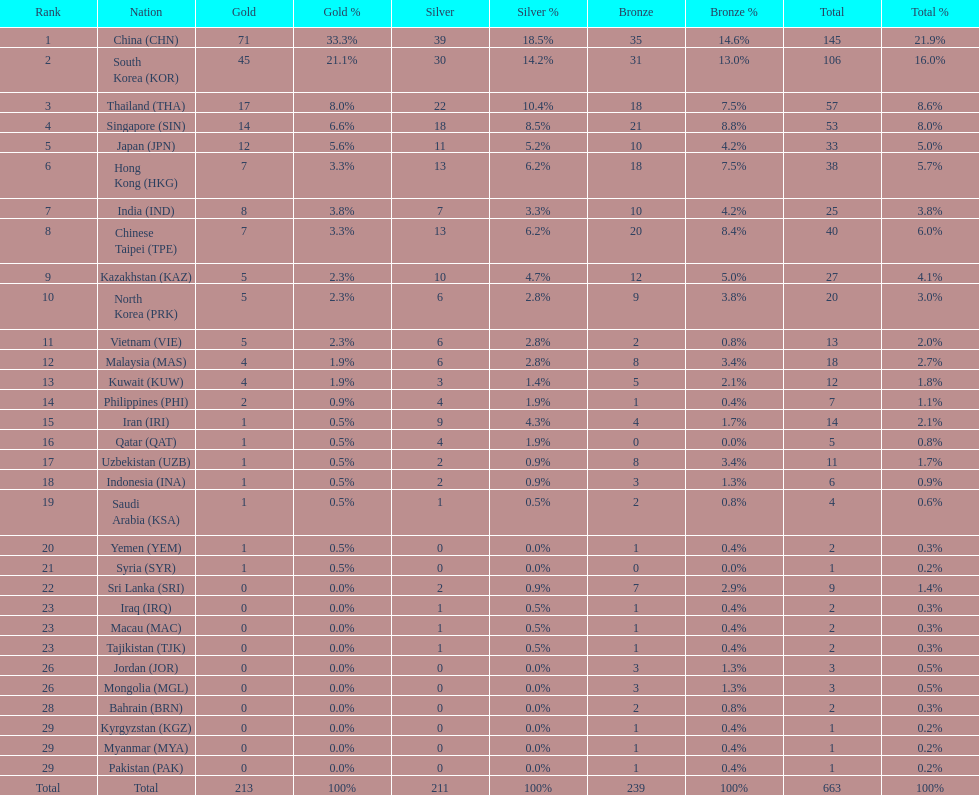How many countries have at least 10 gold medals in the asian youth games? 5. 